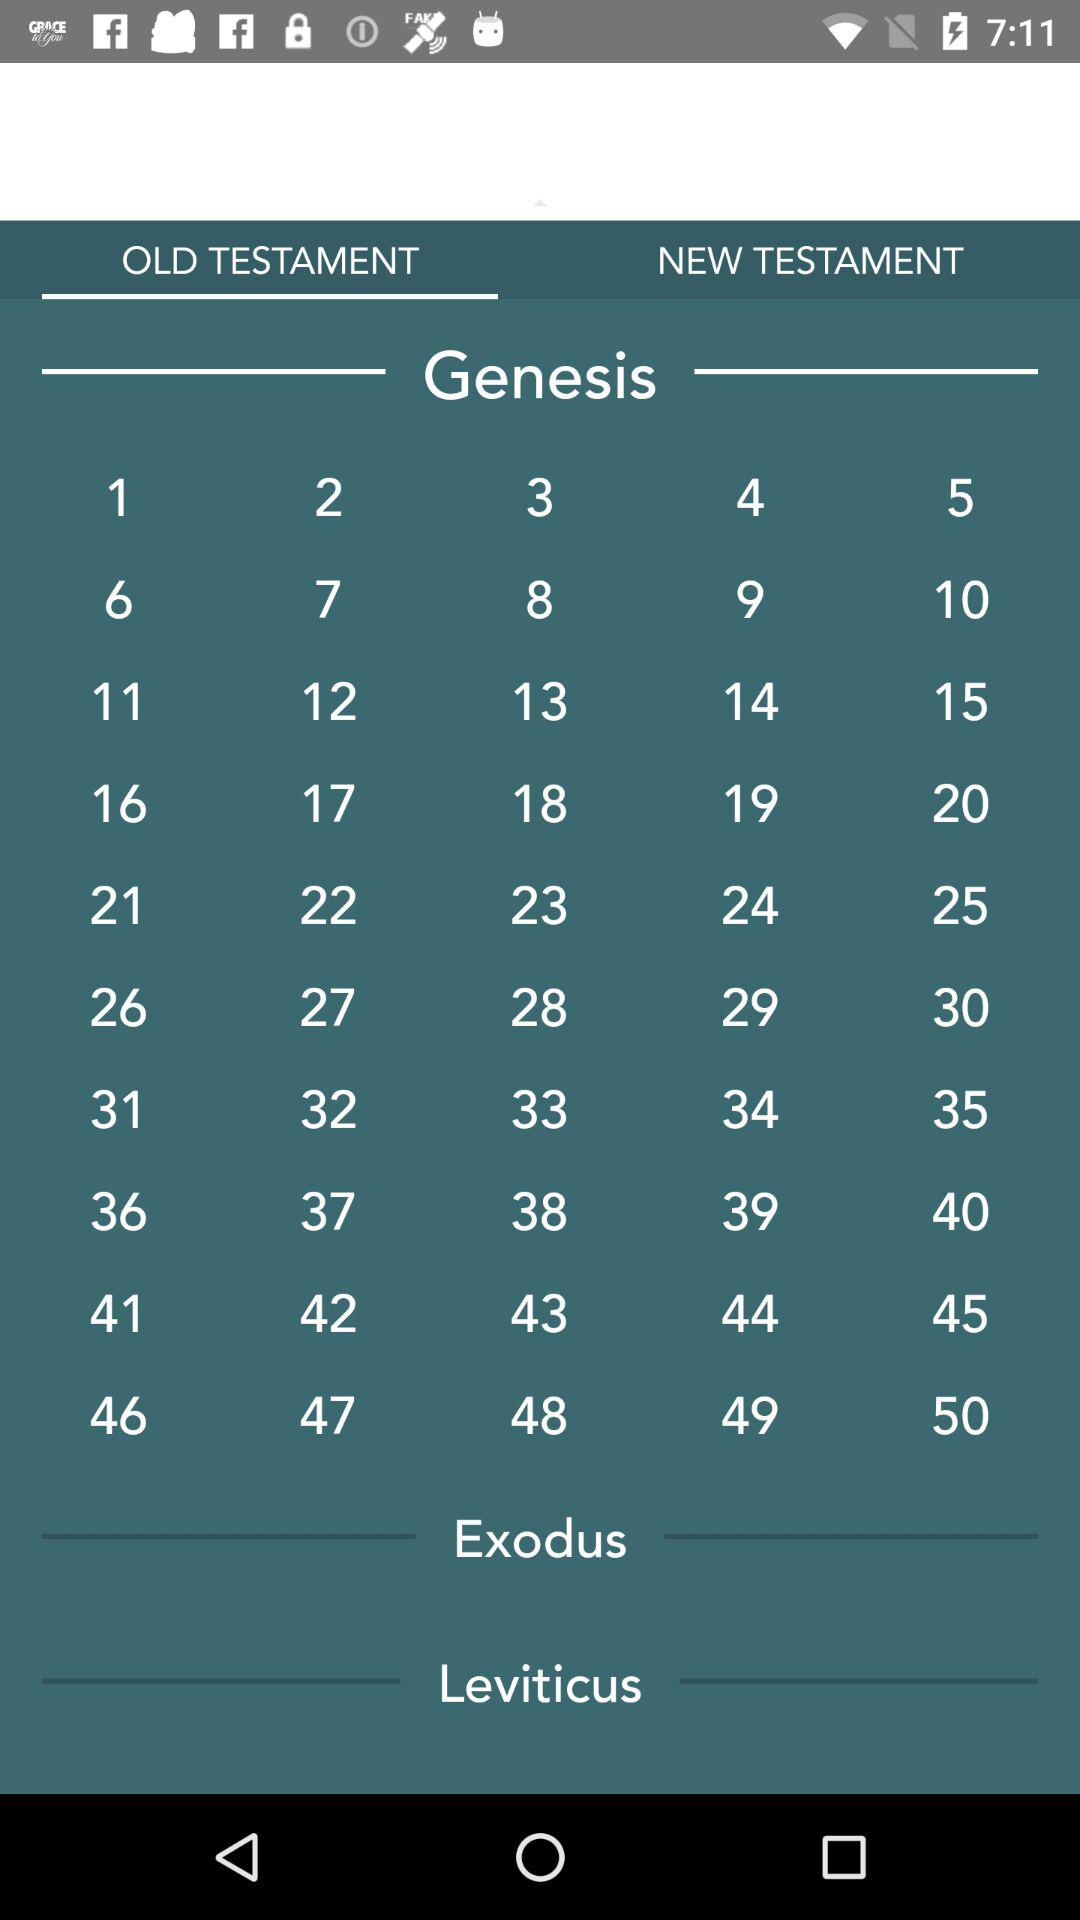Which tab is selected for Genesis? The selected tab is "OLD TESTAMENT". 